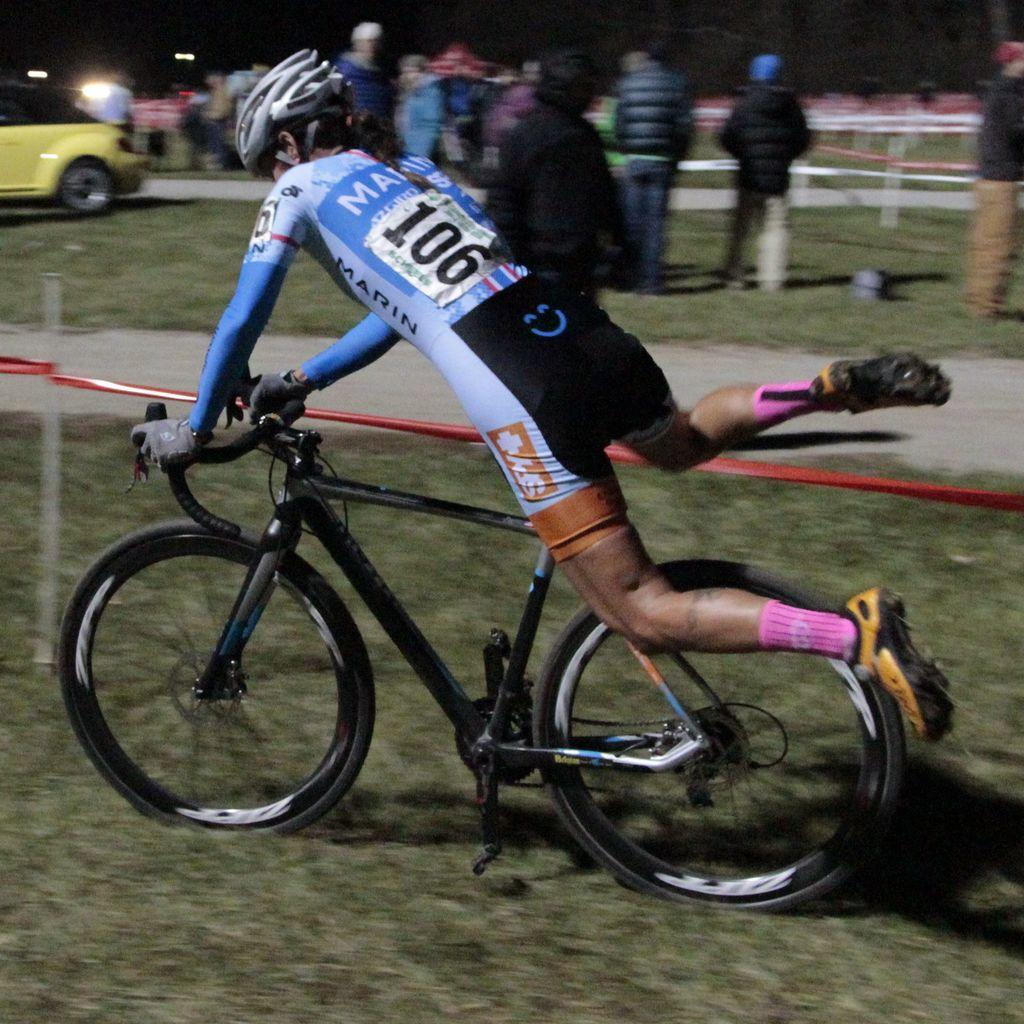Who is the main subject in the image? There is a man in the image. What is the man doing in the image? The man is riding a bicycle. What can be seen on the left side of the image? There is a light and a car on the left side of the image. What type of soda is being served at the committee meeting in the image? There is no committee meeting or soda present in the image. How is the man transporting himself in the image? The man is transporting himself by riding a bicycle in the image. 